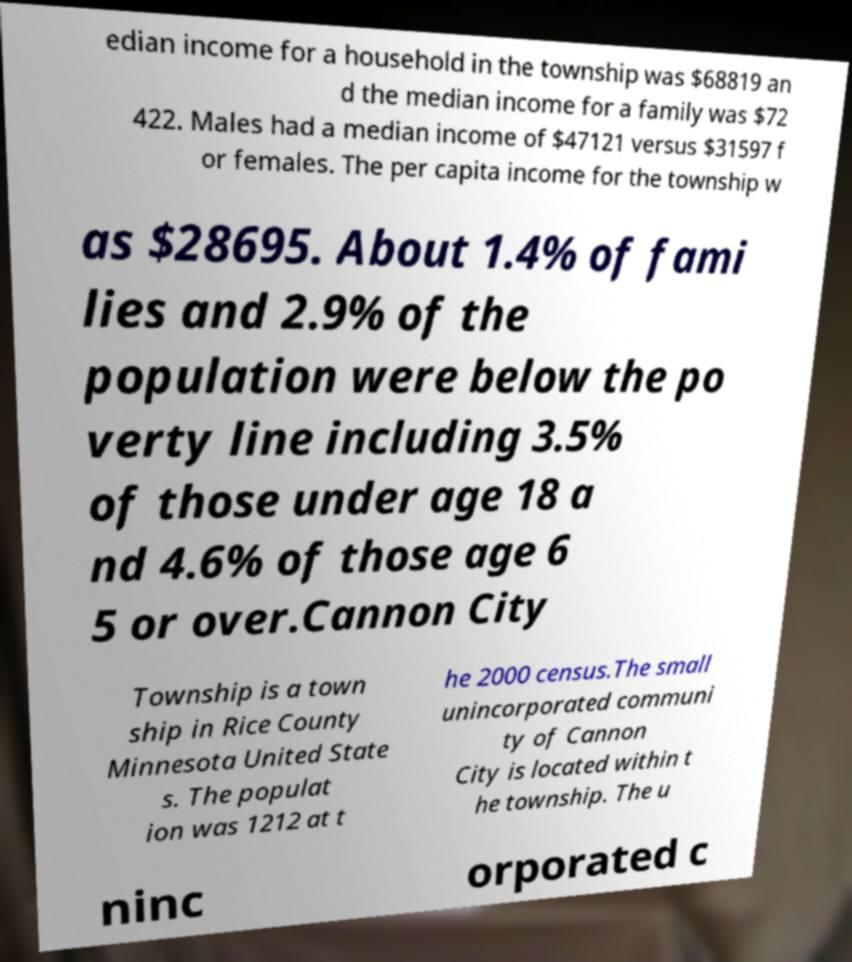Can you accurately transcribe the text from the provided image for me? edian income for a household in the township was $68819 an d the median income for a family was $72 422. Males had a median income of $47121 versus $31597 f or females. The per capita income for the township w as $28695. About 1.4% of fami lies and 2.9% of the population were below the po verty line including 3.5% of those under age 18 a nd 4.6% of those age 6 5 or over.Cannon City Township is a town ship in Rice County Minnesota United State s. The populat ion was 1212 at t he 2000 census.The small unincorporated communi ty of Cannon City is located within t he township. The u ninc orporated c 